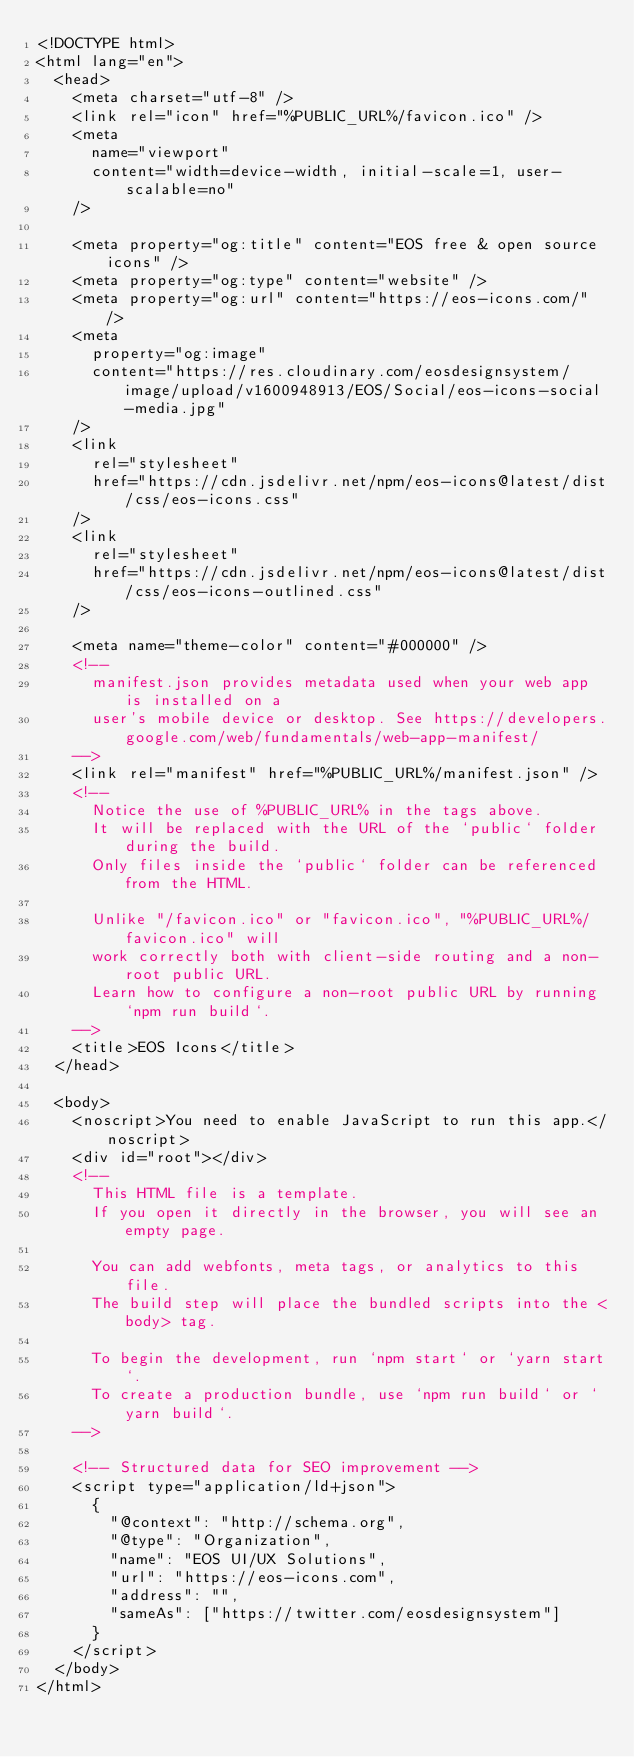Convert code to text. <code><loc_0><loc_0><loc_500><loc_500><_HTML_><!DOCTYPE html>
<html lang="en">
  <head>
    <meta charset="utf-8" />
    <link rel="icon" href="%PUBLIC_URL%/favicon.ico" />
    <meta
      name="viewport"
      content="width=device-width, initial-scale=1, user-scalable=no"
    />

    <meta property="og:title" content="EOS free & open source icons" />
    <meta property="og:type" content="website" />
    <meta property="og:url" content="https://eos-icons.com/" />
    <meta
      property="og:image"
      content="https://res.cloudinary.com/eosdesignsystem/image/upload/v1600948913/EOS/Social/eos-icons-social-media.jpg"
    />
    <link
      rel="stylesheet"
      href="https://cdn.jsdelivr.net/npm/eos-icons@latest/dist/css/eos-icons.css"
    />
    <link
      rel="stylesheet"
      href="https://cdn.jsdelivr.net/npm/eos-icons@latest/dist/css/eos-icons-outlined.css"
    />

    <meta name="theme-color" content="#000000" />
    <!--
      manifest.json provides metadata used when your web app is installed on a
      user's mobile device or desktop. See https://developers.google.com/web/fundamentals/web-app-manifest/
    -->
    <link rel="manifest" href="%PUBLIC_URL%/manifest.json" />
    <!--
      Notice the use of %PUBLIC_URL% in the tags above.
      It will be replaced with the URL of the `public` folder during the build.
      Only files inside the `public` folder can be referenced from the HTML.

      Unlike "/favicon.ico" or "favicon.ico", "%PUBLIC_URL%/favicon.ico" will
      work correctly both with client-side routing and a non-root public URL.
      Learn how to configure a non-root public URL by running `npm run build`.
    -->
    <title>EOS Icons</title>
  </head>

  <body>
    <noscript>You need to enable JavaScript to run this app.</noscript>
    <div id="root"></div>
    <!--
      This HTML file is a template.
      If you open it directly in the browser, you will see an empty page.

      You can add webfonts, meta tags, or analytics to this file.
      The build step will place the bundled scripts into the <body> tag.

      To begin the development, run `npm start` or `yarn start`.
      To create a production bundle, use `npm run build` or `yarn build`.
    -->

    <!-- Structured data for SEO improvement -->
    <script type="application/ld+json">
      {
        "@context": "http://schema.org",
        "@type": "Organization",
        "name": "EOS UI/UX Solutions",
        "url": "https://eos-icons.com",
        "address": "",
        "sameAs": ["https://twitter.com/eosdesignsystem"]
      }
    </script>
  </body>
</html>
</code> 